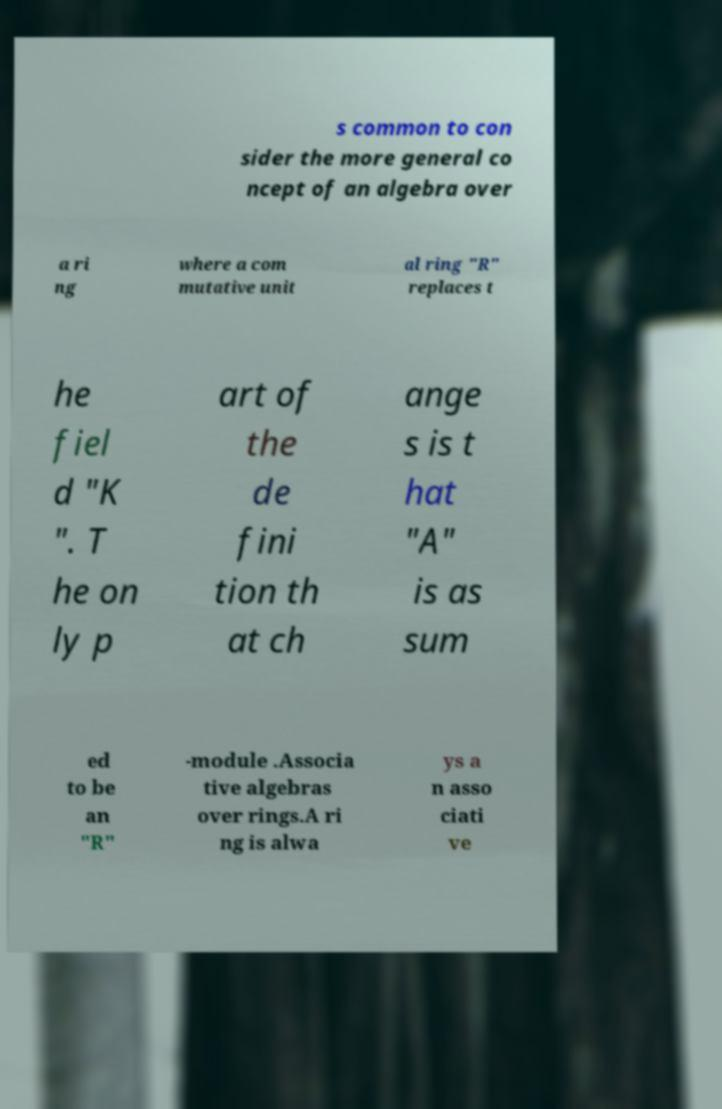Please read and relay the text visible in this image. What does it say? s common to con sider the more general co ncept of an algebra over a ri ng where a com mutative unit al ring "R" replaces t he fiel d "K ". T he on ly p art of the de fini tion th at ch ange s is t hat "A" is as sum ed to be an "R" -module .Associa tive algebras over rings.A ri ng is alwa ys a n asso ciati ve 